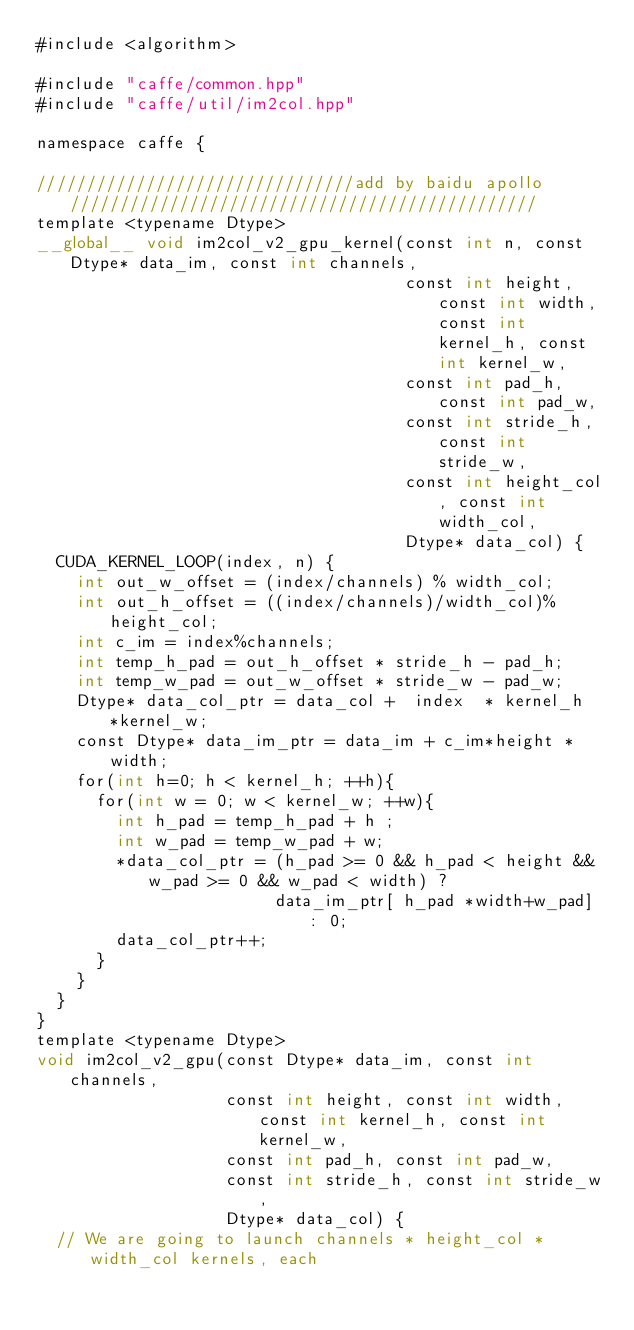Convert code to text. <code><loc_0><loc_0><loc_500><loc_500><_Cuda_>#include <algorithm>

#include "caffe/common.hpp"
#include "caffe/util/im2col.hpp"

namespace caffe {

////////////////////////////////add by baidu apollo ///////////////////////////////////////////////
template <typename Dtype>
__global__ void im2col_v2_gpu_kernel(const int n, const Dtype* data_im, const int channels,
                                     const int height, const int width, const int kernel_h, const int kernel_w,
                                     const int pad_h, const int pad_w,
                                     const int stride_h, const int stride_w,
                                     const int height_col, const int width_col,
                                     Dtype* data_col) {
  CUDA_KERNEL_LOOP(index, n) {
    int out_w_offset = (index/channels) % width_col;
    int out_h_offset = ((index/channels)/width_col)%height_col;
    int c_im = index%channels;
    int temp_h_pad = out_h_offset * stride_h - pad_h;
    int temp_w_pad = out_w_offset * stride_w - pad_w;
    Dtype* data_col_ptr = data_col +  index  * kernel_h  *kernel_w;
    const Dtype* data_im_ptr = data_im + c_im*height *width;
    for(int h=0; h < kernel_h; ++h){
      for(int w = 0; w < kernel_w; ++w){
        int h_pad = temp_h_pad + h ;
        int w_pad = temp_w_pad + w;
        *data_col_ptr = (h_pad >= 0 && h_pad < height && w_pad >= 0 && w_pad < width) ?
                        data_im_ptr[ h_pad *width+w_pad] : 0;
        data_col_ptr++;
      }
    }
  }
}
template <typename Dtype>
void im2col_v2_gpu(const Dtype* data_im, const int channels,
                   const int height, const int width, const int kernel_h, const int kernel_w,
                   const int pad_h, const int pad_w,
                   const int stride_h, const int stride_w,
                   Dtype* data_col) {
  // We are going to launch channels * height_col * width_col kernels, each</code> 